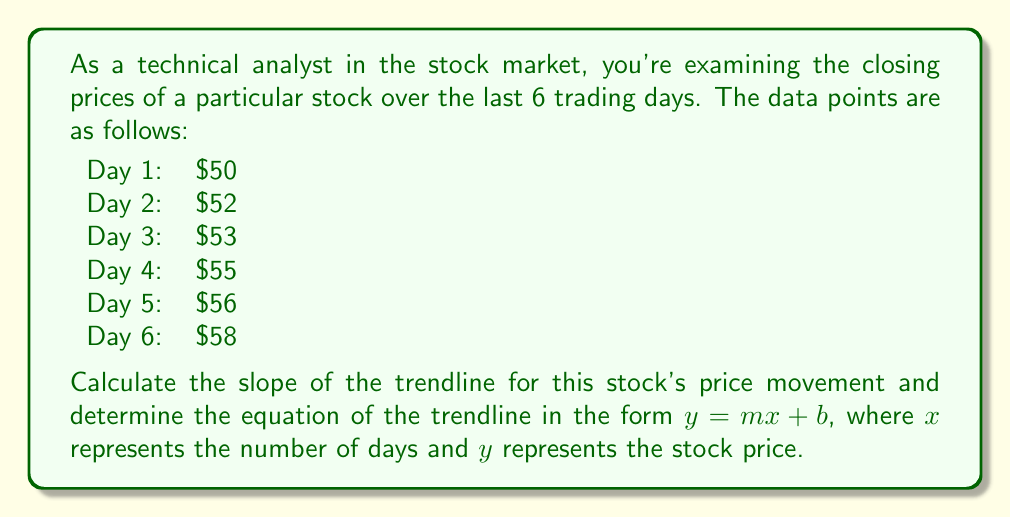Help me with this question. To find the slope and equation of the trendline, we'll use the least squares method:

1. First, let's set up our data:
   $x$ (days): 1, 2, 3, 4, 5, 6
   $y$ (price): 50, 52, 53, 55, 56, 58

2. Calculate the means:
   $\bar{x} = \frac{1 + 2 + 3 + 4 + 5 + 6}{6} = 3.5$
   $\bar{y} = \frac{50 + 52 + 53 + 55 + 56 + 58}{6} = 54$

3. Calculate $\sum (x - \bar{x})(y - \bar{y})$ and $\sum (x - \bar{x})^2$:
   
   $\sum (x - \bar{x})(y - \bar{y}) = (-2.5)(-4) + (-1.5)(-2) + (-0.5)(-1) + (0.5)(1) + (1.5)(2) + (2.5)(4) = 35$
   
   $\sum (x - \bar{x})^2 = (-2.5)^2 + (-1.5)^2 + (-0.5)^2 + (0.5)^2 + (1.5)^2 + (2.5)^2 = 17.5$

4. Calculate the slope (m):
   $$m = \frac{\sum (x - \bar{x})(y - \bar{y})}{\sum (x - \bar{x})^2} = \frac{35}{17.5} = 2$$

5. Find the y-intercept (b) using the point-slope form:
   $y - \bar{y} = m(x - \bar{x})$
   $54 = 2(3.5) + b$
   $b = 54 - 7 = 47$

6. The equation of the trendline is:
   $y = 2x + 47$
Answer: Slope of the trendline: $m = 2$
Equation of the trendline: $y = 2x + 47$ 